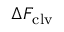<formula> <loc_0><loc_0><loc_500><loc_500>\Delta F _ { c l v }</formula> 